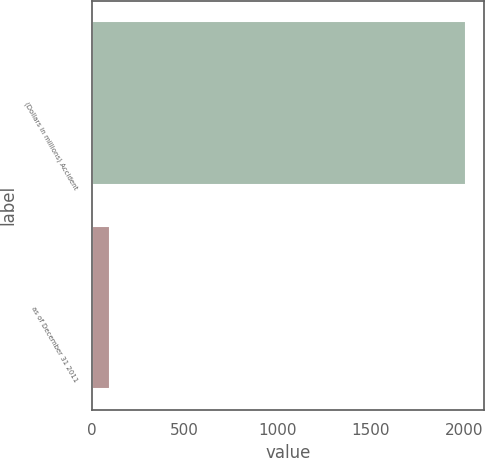<chart> <loc_0><loc_0><loc_500><loc_500><bar_chart><fcel>(Dollars in millions) Accident<fcel>as of December 31 2011<nl><fcel>2011<fcel>100.3<nl></chart> 